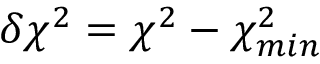Convert formula to latex. <formula><loc_0><loc_0><loc_500><loc_500>\delta \chi ^ { 2 } = \chi ^ { 2 } - \chi _ { \min } ^ { 2 }</formula> 